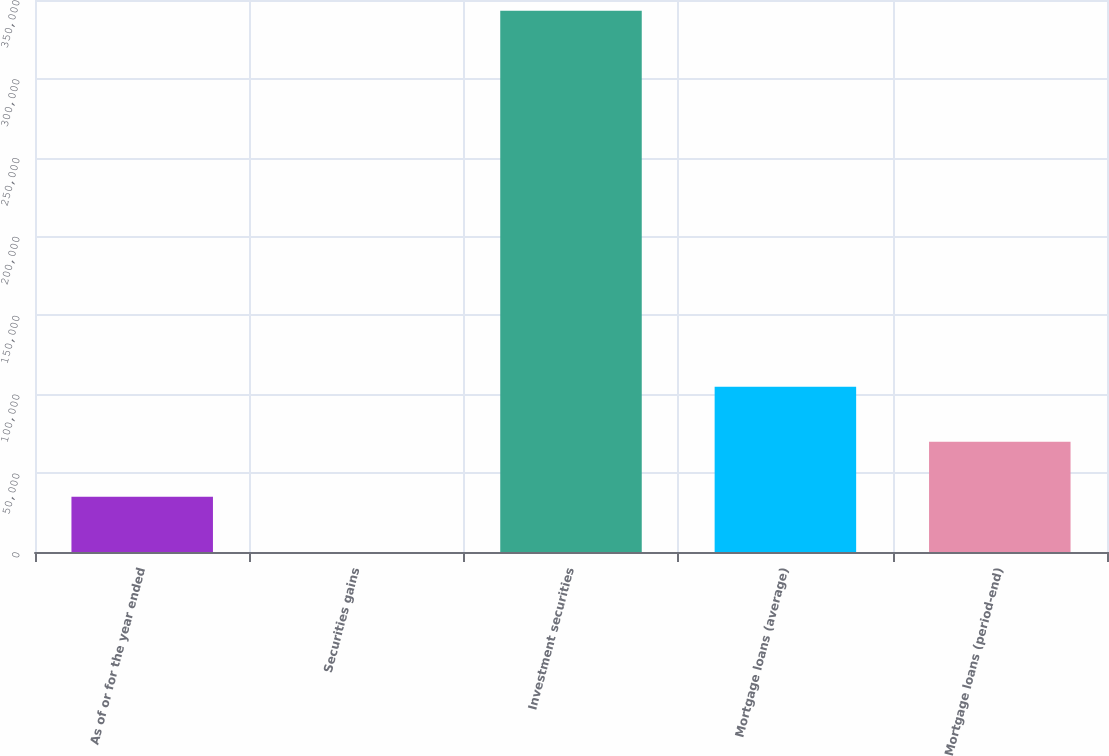Convert chart to OTSL. <chart><loc_0><loc_0><loc_500><loc_500><bar_chart><fcel>As of or for the year ended<fcel>Securities gains<fcel>Investment securities<fcel>Mortgage loans (average)<fcel>Mortgage loans (period-end)<nl><fcel>34992.4<fcel>71<fcel>343146<fcel>104835<fcel>69913.8<nl></chart> 